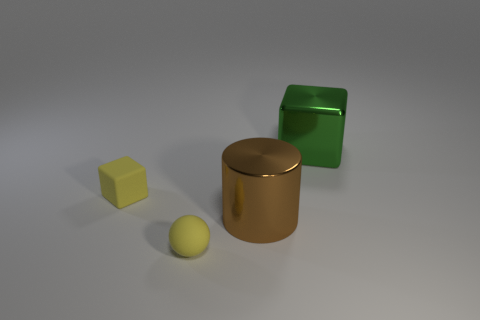There is a green thing that is made of the same material as the big brown object; what shape is it?
Offer a very short reply. Cube. Does the yellow matte thing in front of the cylinder have the same size as the metallic thing that is behind the large brown thing?
Your answer should be very brief. No. What is the shape of the big metallic thing that is in front of the green thing?
Your answer should be compact. Cylinder. The rubber block is what color?
Ensure brevity in your answer.  Yellow. Do the brown cylinder and the block left of the big green cube have the same size?
Your response must be concise. No. How many metallic objects are tiny green cylinders or big green blocks?
Offer a very short reply. 1. There is a tiny rubber ball; does it have the same color as the cube that is left of the cylinder?
Provide a short and direct response. Yes. What is the shape of the large green shiny object?
Provide a succinct answer. Cube. What is the size of the yellow object that is left of the small yellow object that is in front of the matte cube in front of the green shiny block?
Offer a very short reply. Small. How many other objects are there of the same shape as the big brown metal thing?
Your answer should be very brief. 0. 